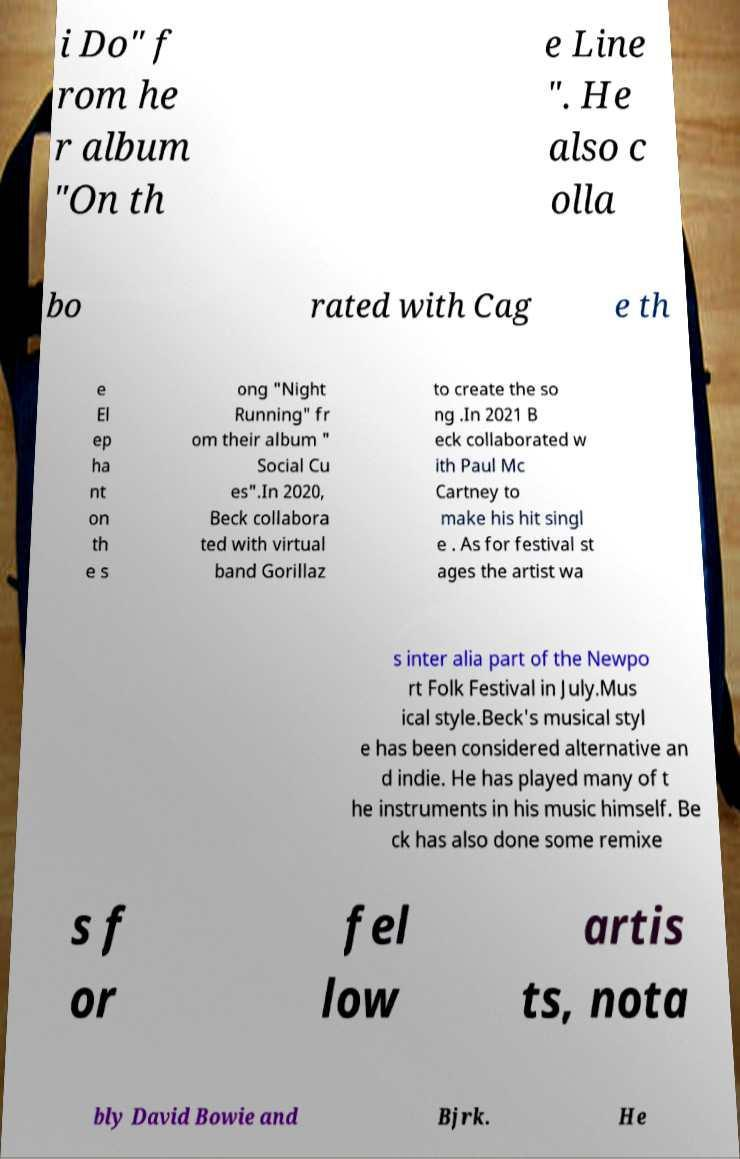Please identify and transcribe the text found in this image. i Do" f rom he r album "On th e Line ". He also c olla bo rated with Cag e th e El ep ha nt on th e s ong "Night Running" fr om their album " Social Cu es".In 2020, Beck collabora ted with virtual band Gorillaz to create the so ng .In 2021 B eck collaborated w ith Paul Mc Cartney to make his hit singl e . As for festival st ages the artist wa s inter alia part of the Newpo rt Folk Festival in July.Mus ical style.Beck's musical styl e has been considered alternative an d indie. He has played many of t he instruments in his music himself. Be ck has also done some remixe s f or fel low artis ts, nota bly David Bowie and Bjrk. He 